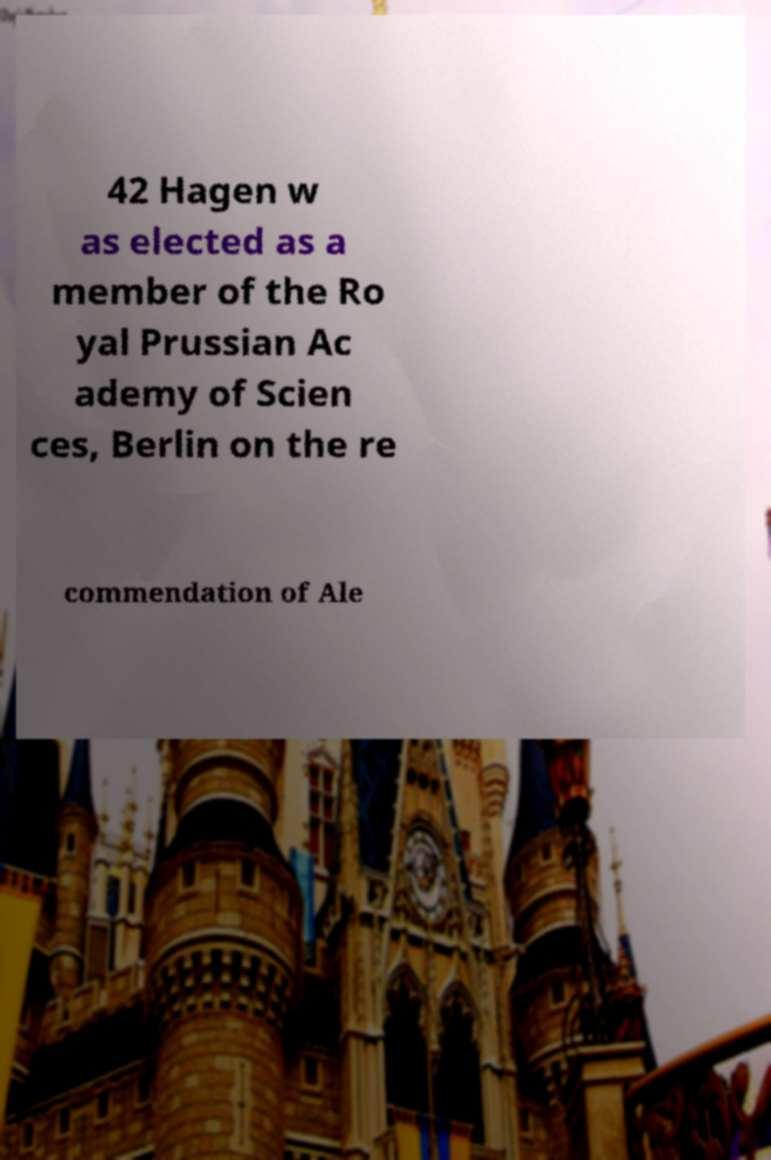What messages or text are displayed in this image? I need them in a readable, typed format. 42 Hagen w as elected as a member of the Ro yal Prussian Ac ademy of Scien ces, Berlin on the re commendation of Ale 